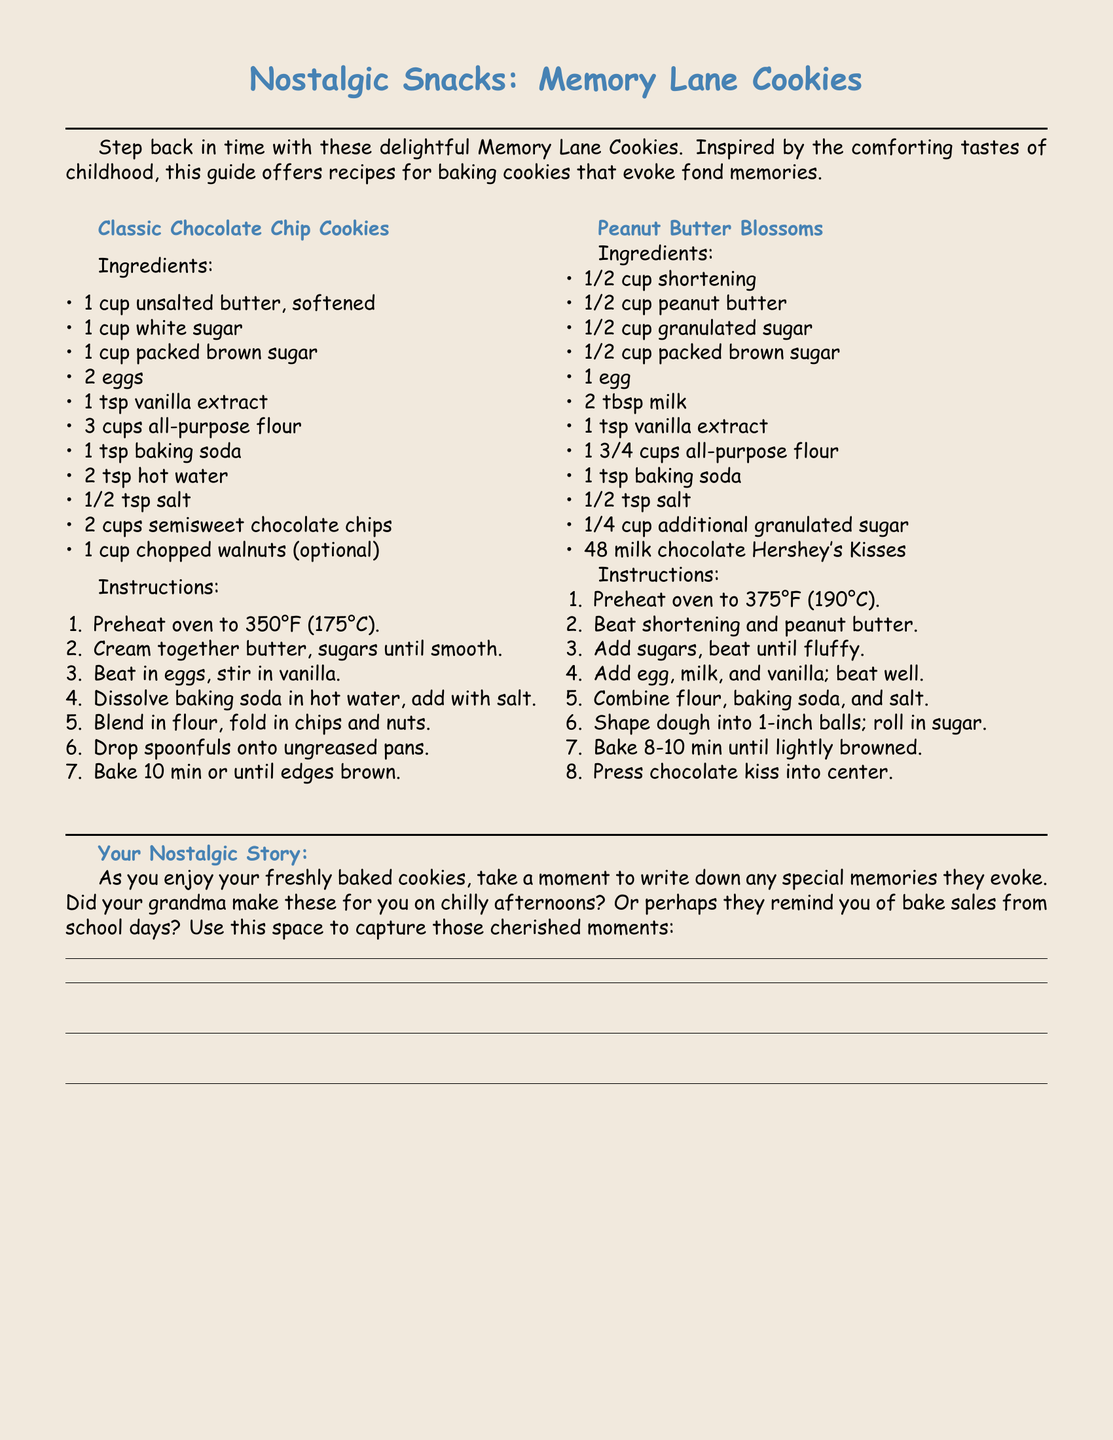What is the title of the recipe card? The title of the recipe card is prominently displayed at the top of the document, indicating the focus of the content.
Answer: Nostalgic Snacks: Memory Lane Cookies How many cookies does the classic chocolate chip cookie recipe yield? The document does not specify the yield, but typically a standard recipe makes about 24 cookies.
Answer: 24 What is the main ingredient in Peanut Butter Blossoms? The main ingredient is highlighted in the ingredients list for this specific recipe.
Answer: Peanut butter What temperature do you preheat the oven for classic chocolate chip cookies? The preheating temperature is provided in the instructions section of the recipe.
Answer: 350°F Which flavor variation includes a chocolate kiss? This question identifies the specific cookie recipe that features this distinct ingredient.
Answer: Peanut Butter Blossoms What is a suggested activity while baking the cookies? The document encourages personal reflection and storytelling during the baking process.
Answer: Write down nostalgic stories How many eggs are needed for the classic chocolate chip cookie recipe? The ingredients list specifies the number of eggs required for this recipe.
Answer: 2 What is the last step in the classic chocolate chip cookie recipe? The last step summarizes the final action before enjoying the cookies.
Answer: Bake 10 min or until edges brown What color is the page background? The document illustrates the design elements, including the background color which contributes to the overall aesthetic.
Answer: Cookie brown 